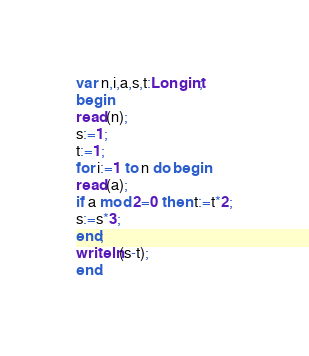Convert code to text. <code><loc_0><loc_0><loc_500><loc_500><_Pascal_>var n,i,a,s,t:Longint;
begin
read(n);
s:=1;
t:=1;
for i:=1 to n do begin
read(a);
if a mod 2=0 then t:=t*2;
s:=s*3;
end;
writeln(s-t);
end.</code> 